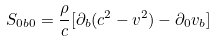<formula> <loc_0><loc_0><loc_500><loc_500>S _ { 0 b 0 } = \frac { \rho } { c } [ { \partial } _ { b } ( c ^ { 2 } - v ^ { 2 } ) - { \partial } _ { 0 } v _ { b } ]</formula> 